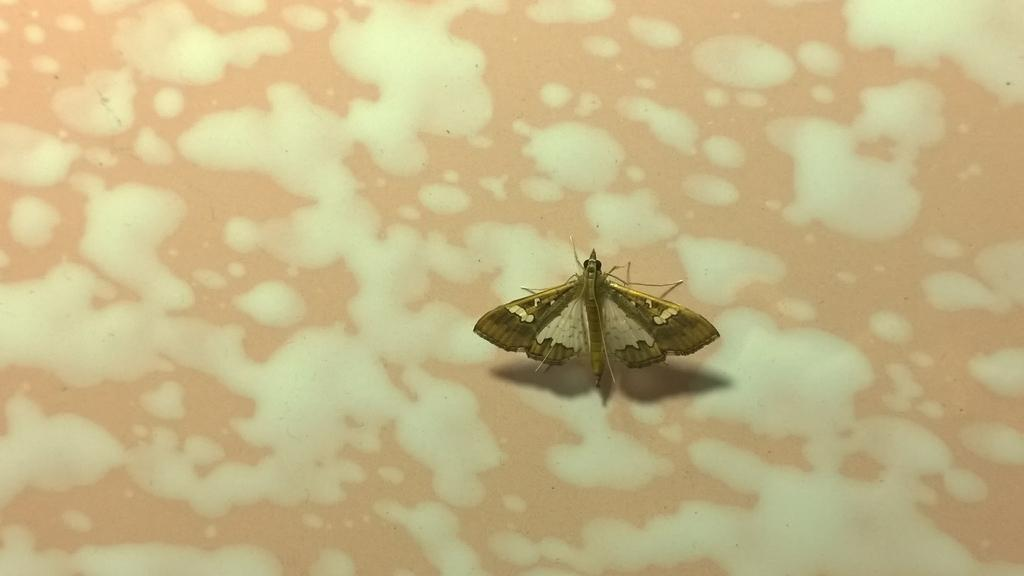What type of creature is present in the image? There is an insect in the image. What colors can be seen on the insect? The insect has green, black, and cream colors. What colors are present in the background of the image? The background of the image is brown and cream colored. What historical event is depicted in the image? There is no historical event depicted in the image; it features an insect with specific colors against a brown and cream background. 